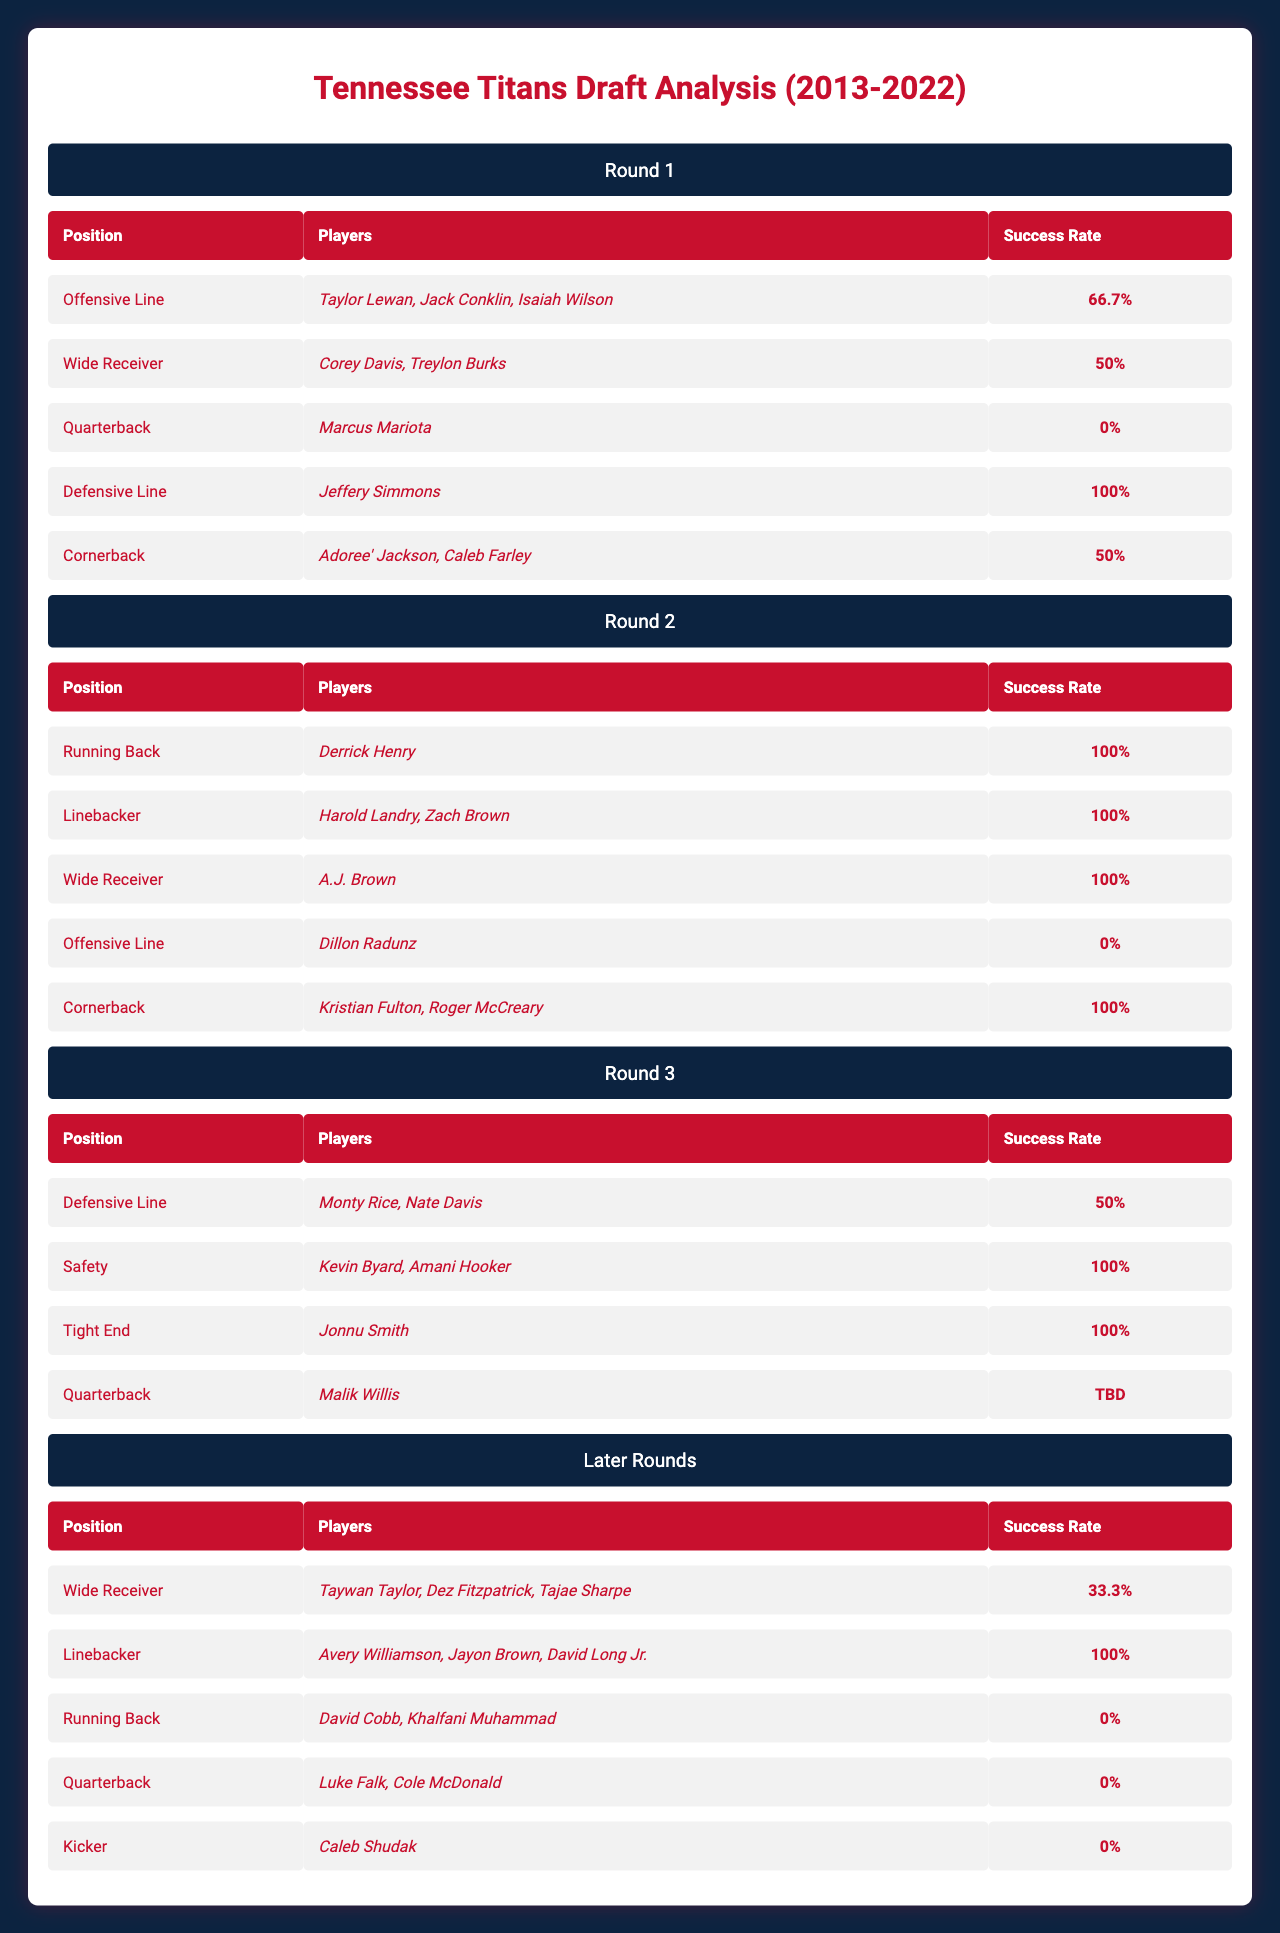What is the success rate for Offensive Line picks in Round 1? The table shows that the success rate for Offensive Line picks in Round 1 is stated as "66.7%."
Answer: 66.7% Which position had the highest success rate in Round 2? By reviewing the data in Round 2, the success rates for Running Back, Linebacker, Wide Receiver, and Cornerback are all "100%." Therefore, the highest success rate for any position in Round 2 is "100%."
Answer: 100% How many players were drafted as Quarterbacks in the last decade? The table lists quarterbacks from Round 1 (Marcus Mariota), Round 3 (Malik Willis), and Later Rounds (Luke Falk & Cole McDonald), indicating a total of 4 quarterbacks drafted.
Answer: 4 Is the success rate for Tight End picks in Round 3 higher or lower than the success rate for Quarterback picks in that same round? The success rate for Tight End (Jonnu Smith) in Round 3 is "100%," while for Quarterback (Malik Willis) it is "TBD." Therefore, the Tight End's success rate is higher when compared directly.
Answer: Higher What is the average success rate for Wide Receiver picks across all rounds? Wide Receiver success rates are: 50% (Round 1), 100% (Round 2), 33.3% (Later Rounds). To find the average: (50 + 100 + 33.3) / 3 = 61.1%.
Answer: 61.1% Are there any positions in the Later Rounds with a success rate of 100%? The data indicates that Linebacker (Avery Williamson, Jayon Brown, David Long Jr.) in Later Rounds has a success rate of "100%." Thus, the statement is true.
Answer: Yes Which round had the lowest success rate for its players? The Later Rounds have two positions (Running Back and Quarterback) both with a success rate of "0%," indicating this round had the lowest success rates among all players.
Answer: Later Rounds What position has the highest success rate among all drafted players combined? By examining each round's success rates, Defensive Line (with Jeffery Simmons in Round 1) has a "100%" success rate. No other position matches this across all rounds.
Answer: Defensive Line 